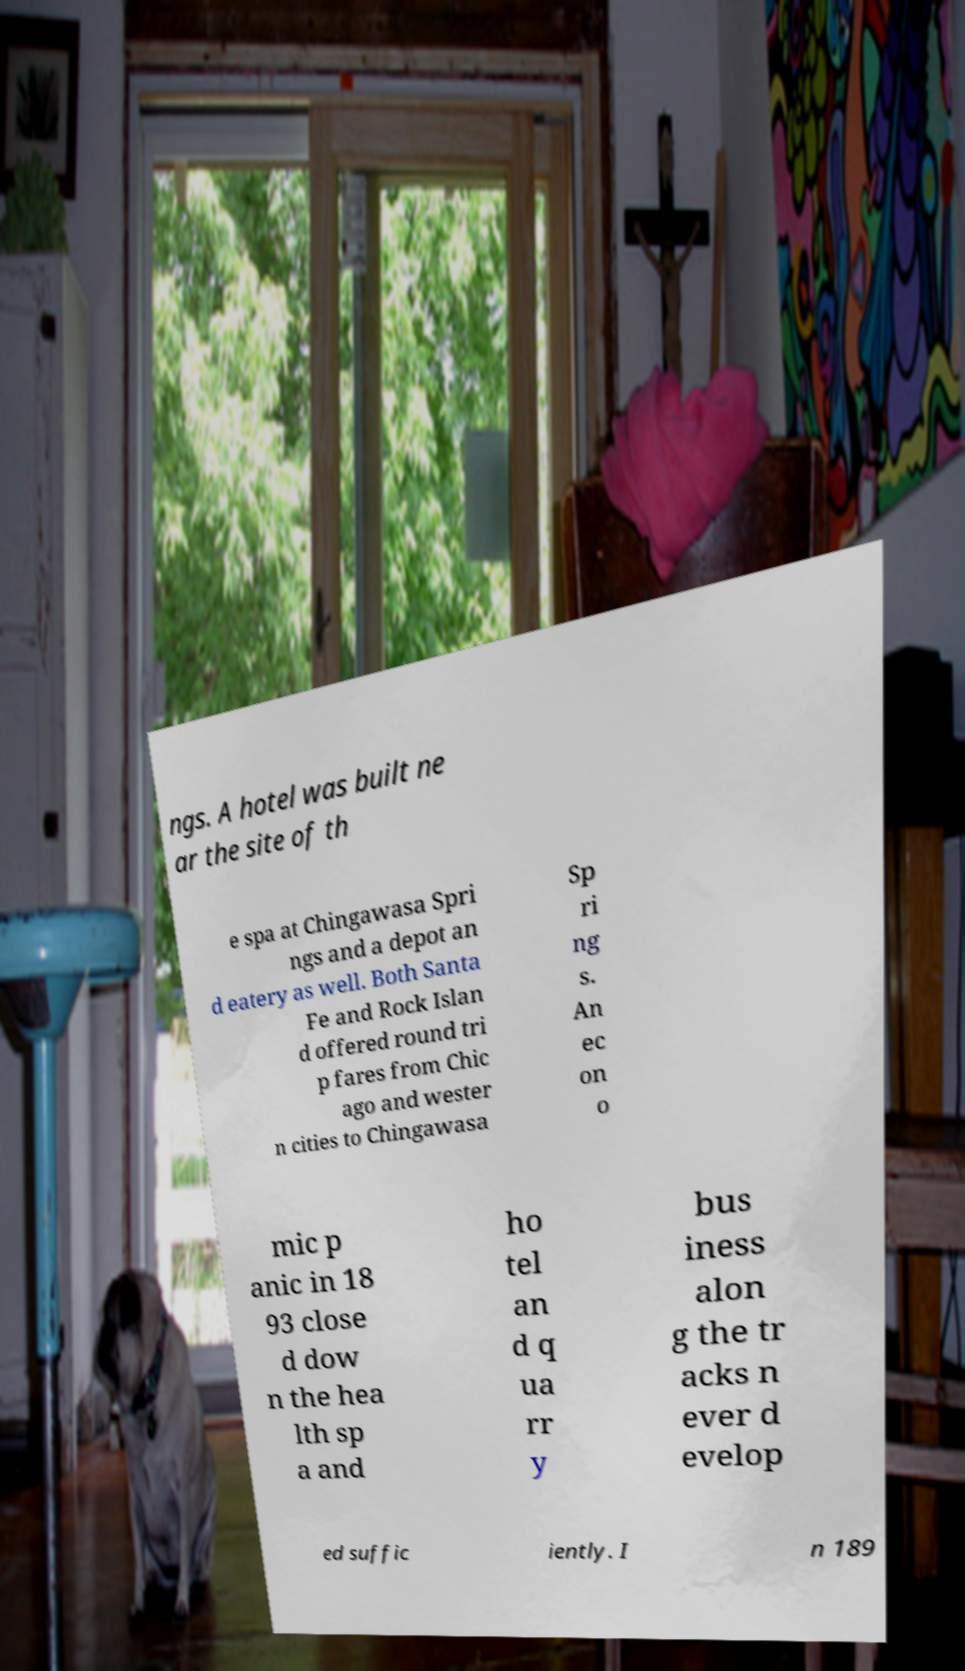What messages or text are displayed in this image? I need them in a readable, typed format. ngs. A hotel was built ne ar the site of th e spa at Chingawasa Spri ngs and a depot an d eatery as well. Both Santa Fe and Rock Islan d offered round tri p fares from Chic ago and wester n cities to Chingawasa Sp ri ng s. An ec on o mic p anic in 18 93 close d dow n the hea lth sp a and ho tel an d q ua rr y bus iness alon g the tr acks n ever d evelop ed suffic iently. I n 189 